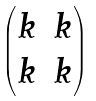<formula> <loc_0><loc_0><loc_500><loc_500>\begin{pmatrix} k & k \\ k & k \end{pmatrix}</formula> 